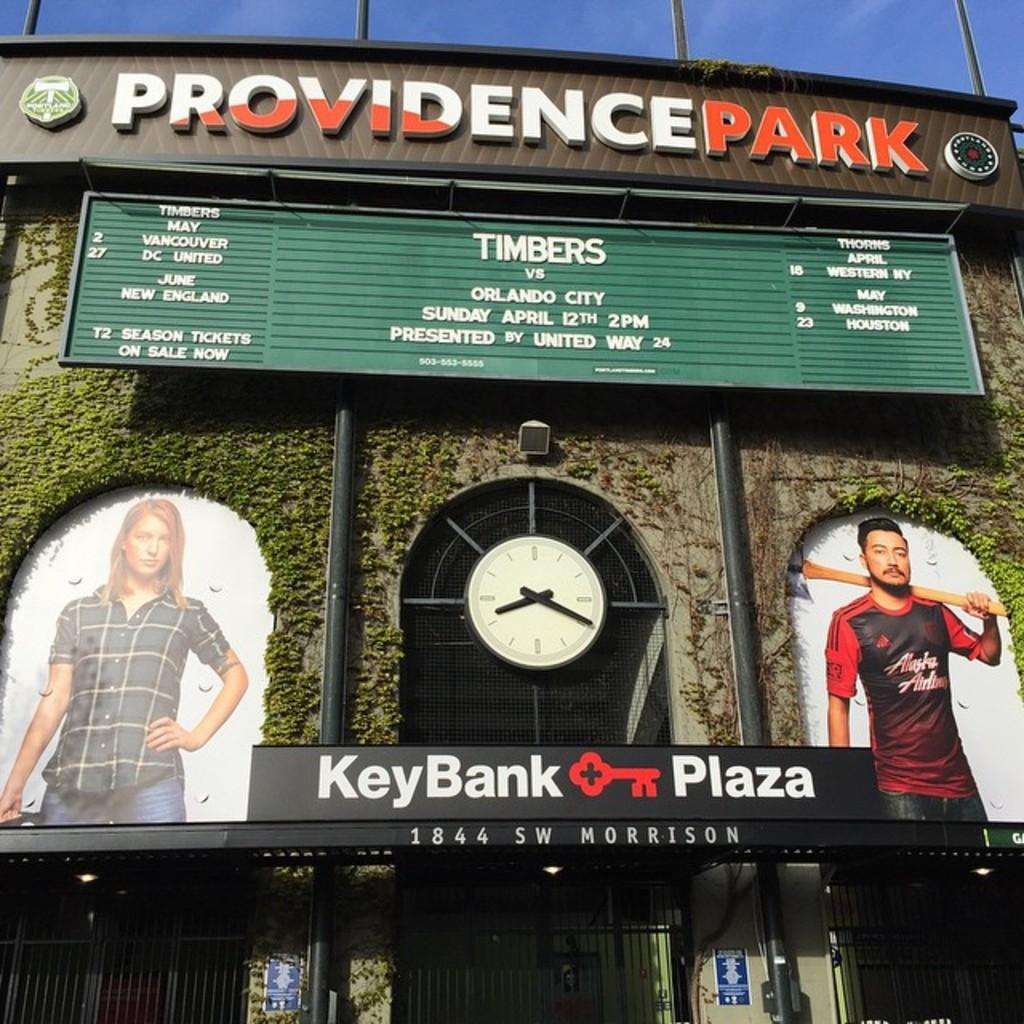<image>
Share a concise interpretation of the image provided. The front entrance of providence park with two people on either side of it. 